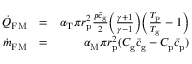Convert formula to latex. <formula><loc_0><loc_0><loc_500><loc_500>\begin{array} { r l r } { \dot { Q } _ { F M } } & { = } & { \alpha _ { T } \pi r _ { p } ^ { 2 } \frac { p \bar { c } _ { g } } { 2 } \left ( \frac { \gamma + 1 } { \gamma - 1 } \right ) \left ( \frac { T _ { p } } { T _ { g } } - 1 \right ) } \\ { \dot { m } _ { F M } } & { = } & { \alpha _ { M } \pi r _ { p } ^ { 2 } ( C _ { g } \bar { c } _ { g } - C _ { p } \bar { c } _ { p } ) } \end{array}</formula> 